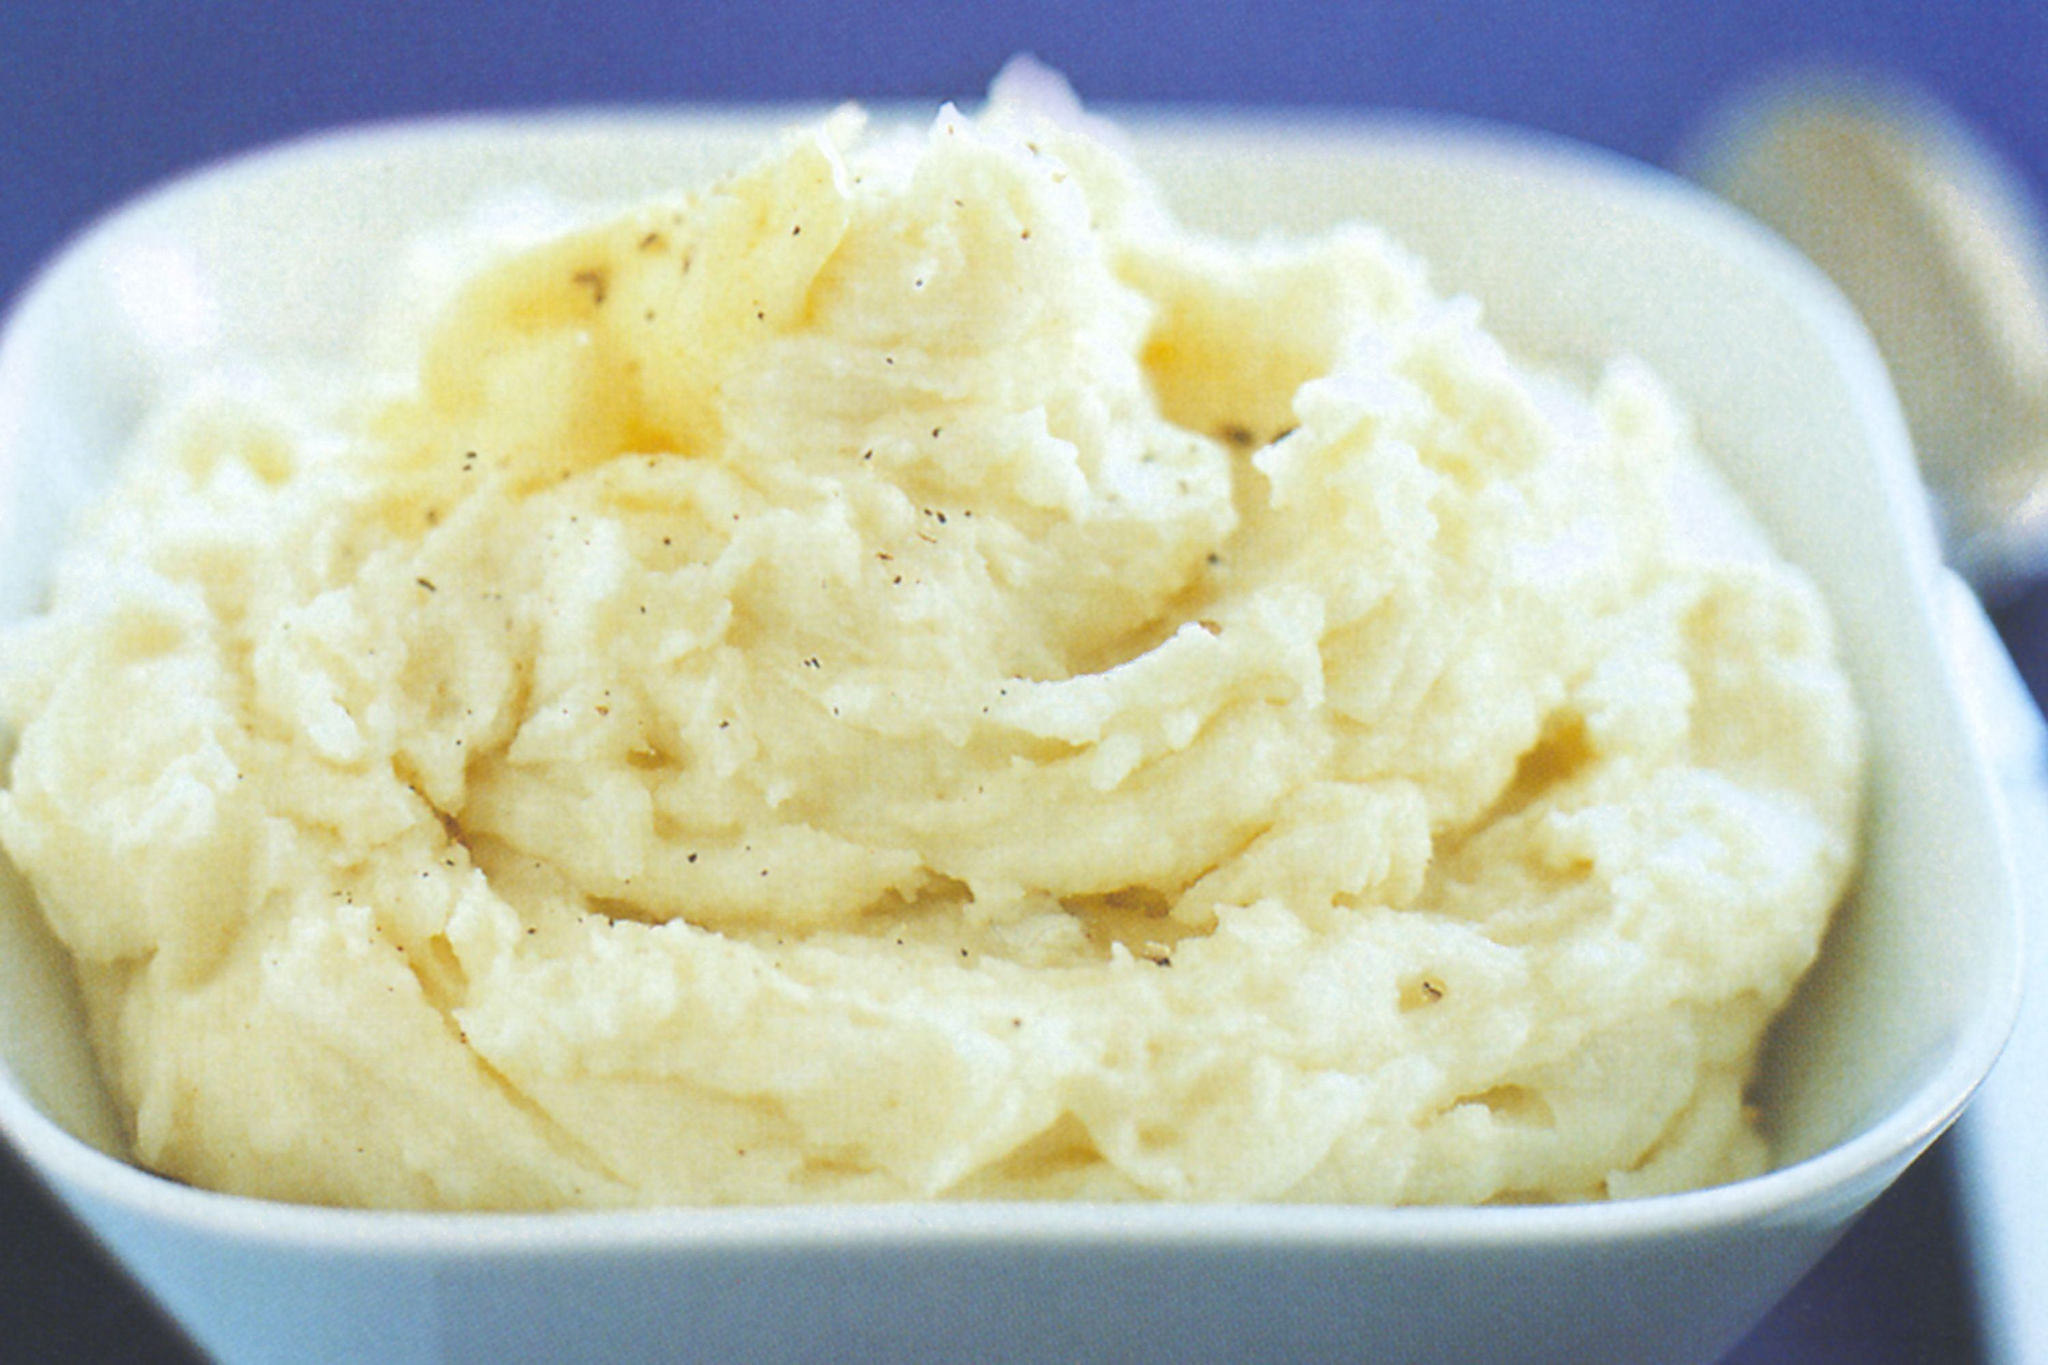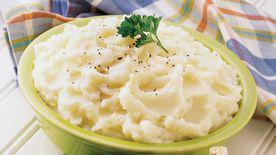The first image is the image on the left, the second image is the image on the right. Given the left and right images, does the statement "One of the mashed potato dishes is squared, with four sides." hold true? Answer yes or no. Yes. The first image is the image on the left, the second image is the image on the right. For the images displayed, is the sentence "There is a green bowl in one of the images" factually correct? Answer yes or no. Yes. The first image is the image on the left, the second image is the image on the right. Assess this claim about the two images: "One image shows mashed potatoes served in a lime-green bowl.". Correct or not? Answer yes or no. Yes. 